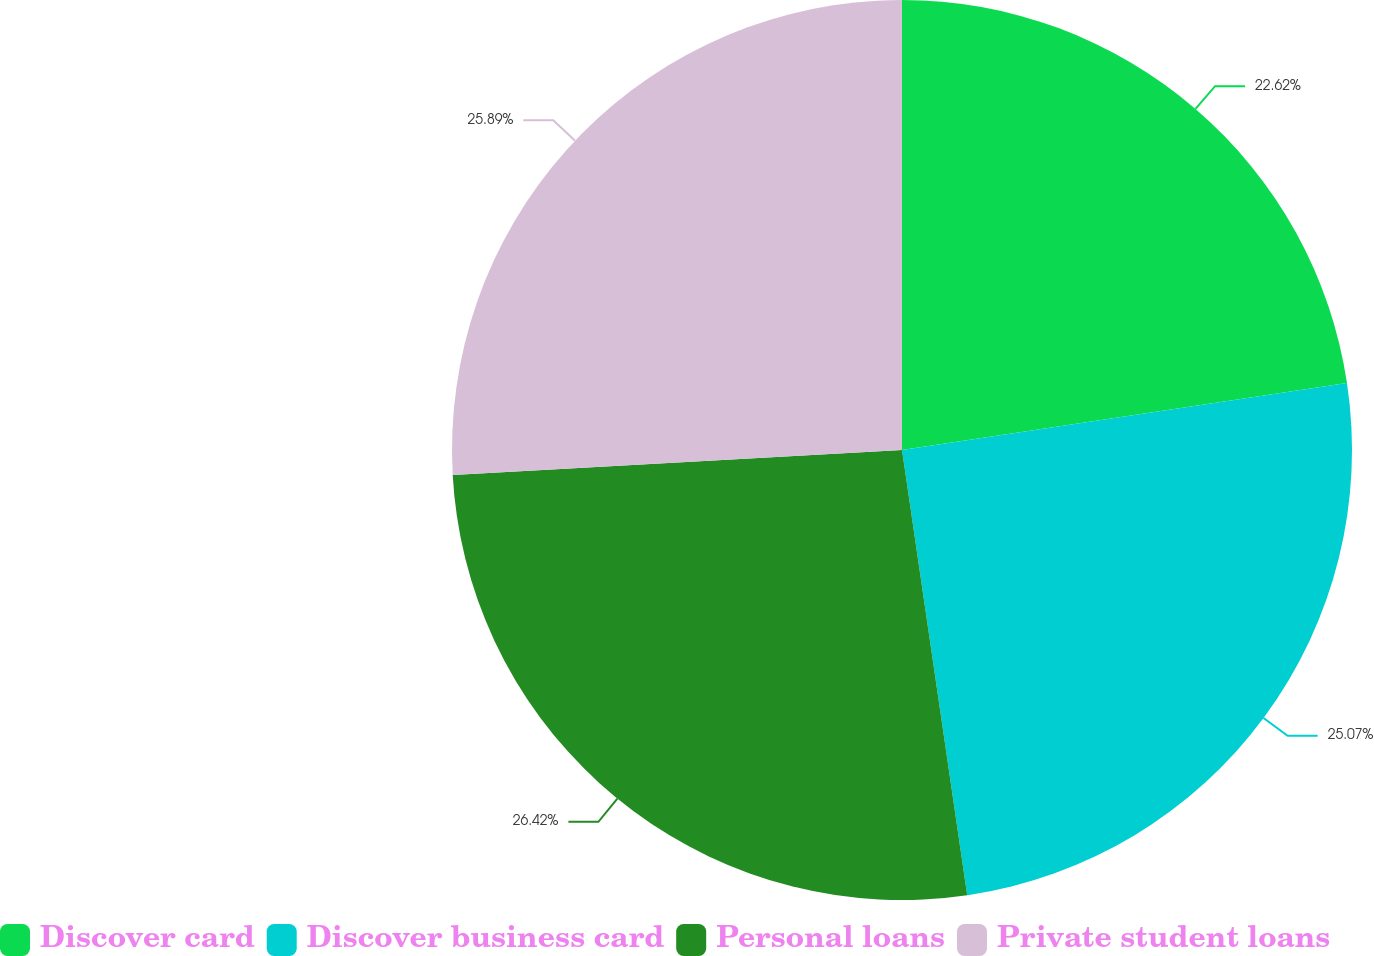Convert chart. <chart><loc_0><loc_0><loc_500><loc_500><pie_chart><fcel>Discover card<fcel>Discover business card<fcel>Personal loans<fcel>Private student loans<nl><fcel>22.62%<fcel>25.07%<fcel>26.43%<fcel>25.89%<nl></chart> 